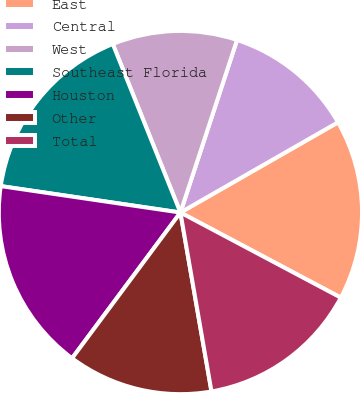<chart> <loc_0><loc_0><loc_500><loc_500><pie_chart><fcel>East<fcel>Central<fcel>West<fcel>Southeast Florida<fcel>Houston<fcel>Other<fcel>Total<nl><fcel>16.04%<fcel>11.68%<fcel>11.12%<fcel>16.6%<fcel>17.15%<fcel>12.91%<fcel>14.5%<nl></chart> 